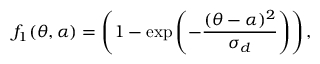Convert formula to latex. <formula><loc_0><loc_0><loc_500><loc_500>f _ { 1 } ( \theta , \alpha ) = \left ( 1 - \exp { \left ( - \frac { ( \theta - \alpha ) ^ { 2 } } { \sigma _ { d } } \right ) } \right ) ,</formula> 